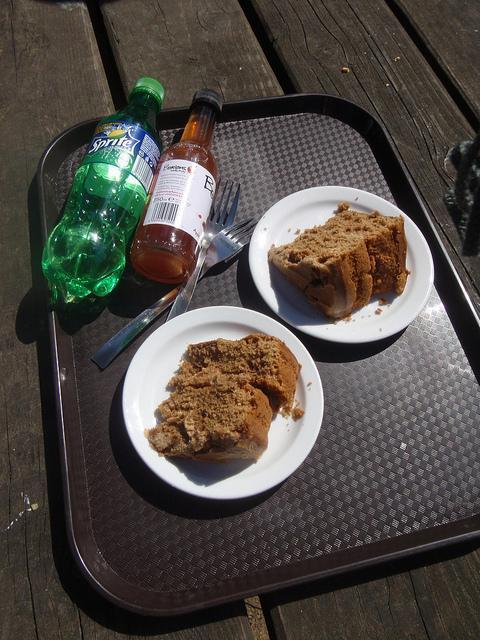How many of the utensils are on the tray?
Give a very brief answer. 2. How many cakes are there?
Give a very brief answer. 3. How many forks can you see?
Give a very brief answer. 2. How many bottles can you see?
Give a very brief answer. 2. 